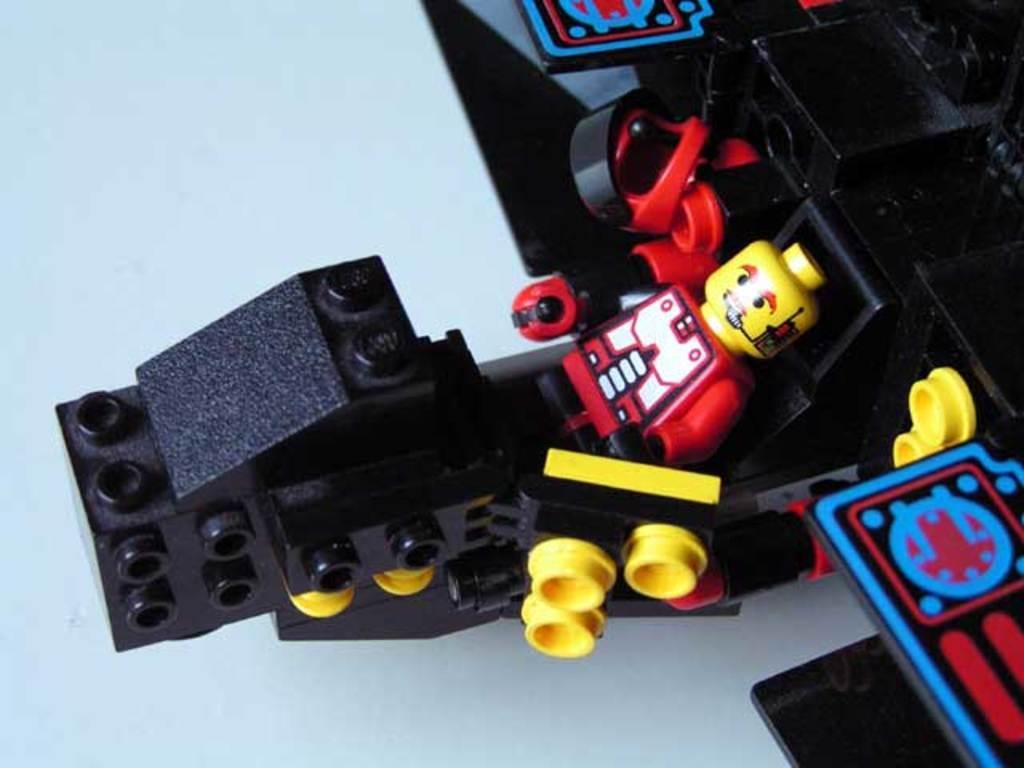Could you give a brief overview of what you see in this image? In this image there are some building blocks and some toys and some objects, at the bottom there might be a floor. 